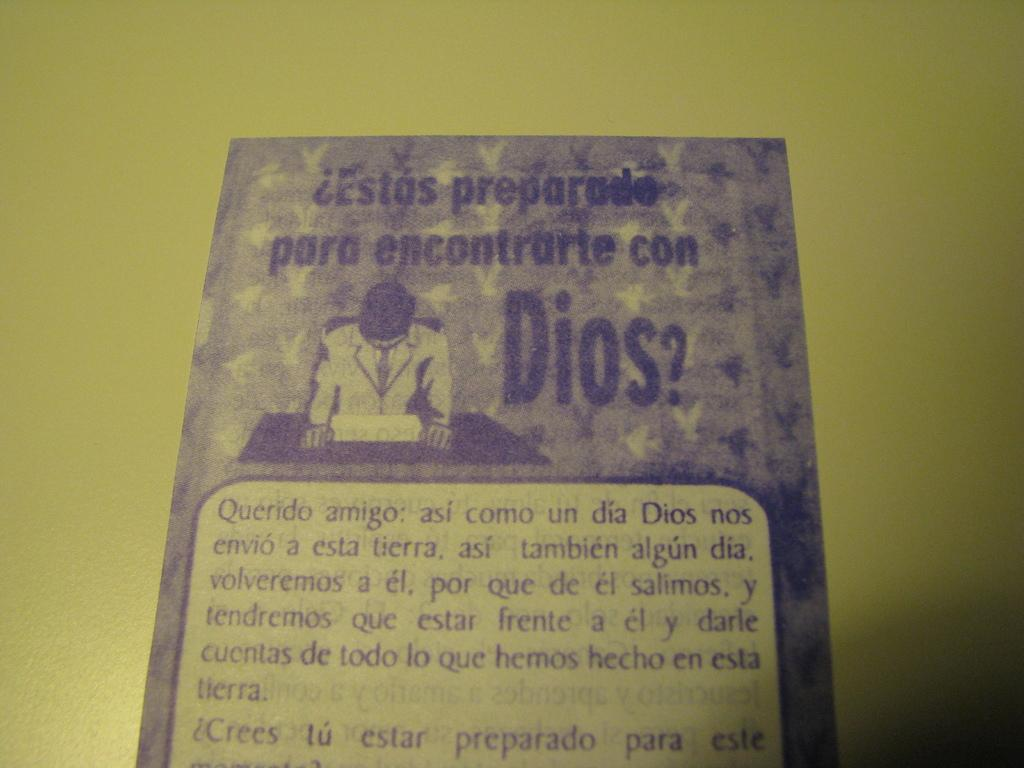<image>
Present a compact description of the photo's key features. A piece of paper that shows a man looking down and all the wording is in spanish. 